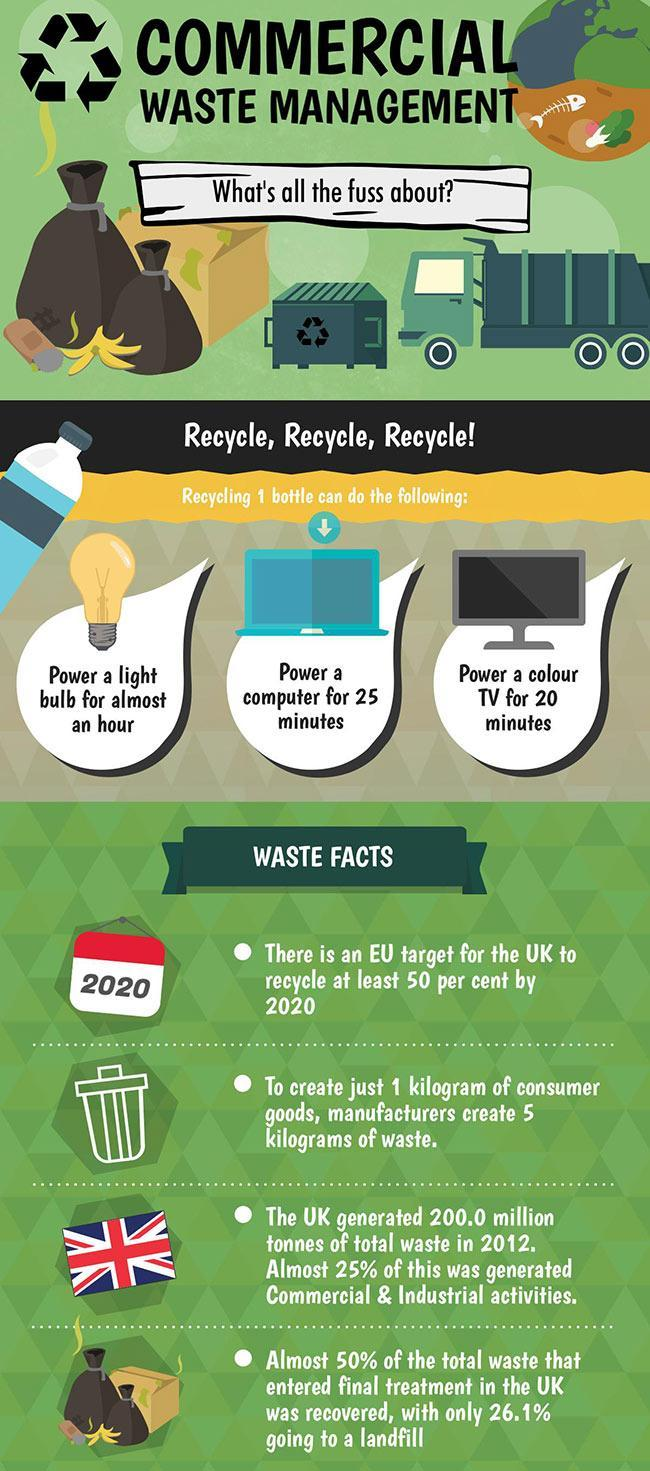What is the image next to the third bullet point - flag, garbage or calendar?
Answer the question with a short phrase. Flag How many bullet points are there under 'waste facts'? 4 What was the share of the total waste (in million tonnes),  generated by commercial and industrial activities? 50 What three electrical appliances shown here, can be powered from a single recycled bottle? Light bulb, computer, colour TV For how long can a PC be powered from one recycled bottle? 25 minutes Which electrical appliance can be powered for 20 minutes, from just 1 recycled bottle? Colour TV How many bottles need to be recycled for powering one light bulb for an hour? 1 